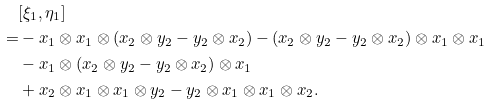<formula> <loc_0><loc_0><loc_500><loc_500>& [ \xi _ { 1 } , \eta _ { 1 } ] \\ = & - x _ { 1 } \otimes x _ { 1 } \otimes ( x _ { 2 } \otimes y _ { 2 } - y _ { 2 } \otimes x _ { 2 } ) - ( x _ { 2 } \otimes y _ { 2 } - y _ { 2 } \otimes x _ { 2 } ) \otimes x _ { 1 } \otimes x _ { 1 } \\ & - x _ { 1 } \otimes ( x _ { 2 } \otimes y _ { 2 } - y _ { 2 } \otimes x _ { 2 } ) \otimes x _ { 1 } \\ & + x _ { 2 } \otimes x _ { 1 } \otimes x _ { 1 } \otimes y _ { 2 } - y _ { 2 } \otimes x _ { 1 } \otimes x _ { 1 } \otimes x _ { 2 } .</formula> 